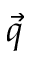<formula> <loc_0><loc_0><loc_500><loc_500>\vec { q }</formula> 